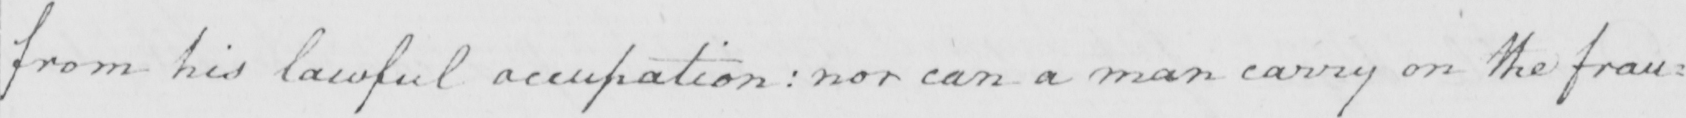What is written in this line of handwriting? from his lawful occupation :  nor can a man carry on the frau= 